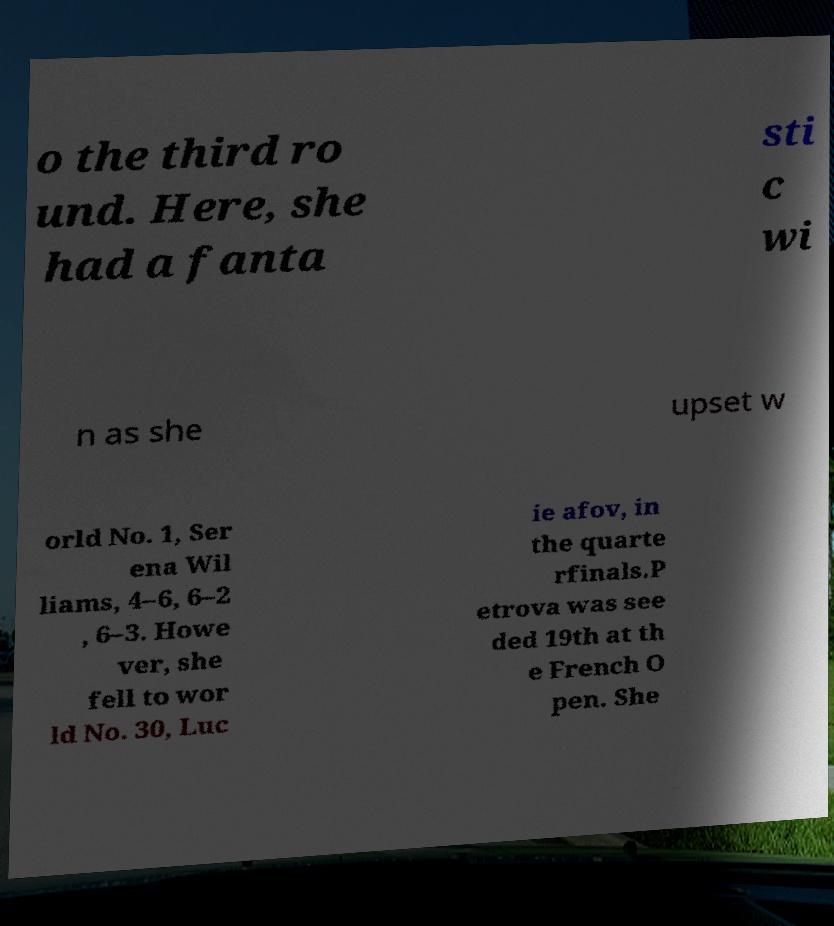I need the written content from this picture converted into text. Can you do that? o the third ro und. Here, she had a fanta sti c wi n as she upset w orld No. 1, Ser ena Wil liams, 4–6, 6–2 , 6–3. Howe ver, she fell to wor ld No. 30, Luc ie afov, in the quarte rfinals.P etrova was see ded 19th at th e French O pen. She 